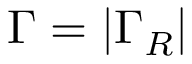<formula> <loc_0><loc_0><loc_500><loc_500>\Gamma = | \Gamma _ { R } |</formula> 